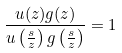Convert formula to latex. <formula><loc_0><loc_0><loc_500><loc_500>\frac { u ( z ) g ( z ) } { u \left ( \frac { s } { z } \right ) g \left ( \frac { s } { z } \right ) } = 1</formula> 